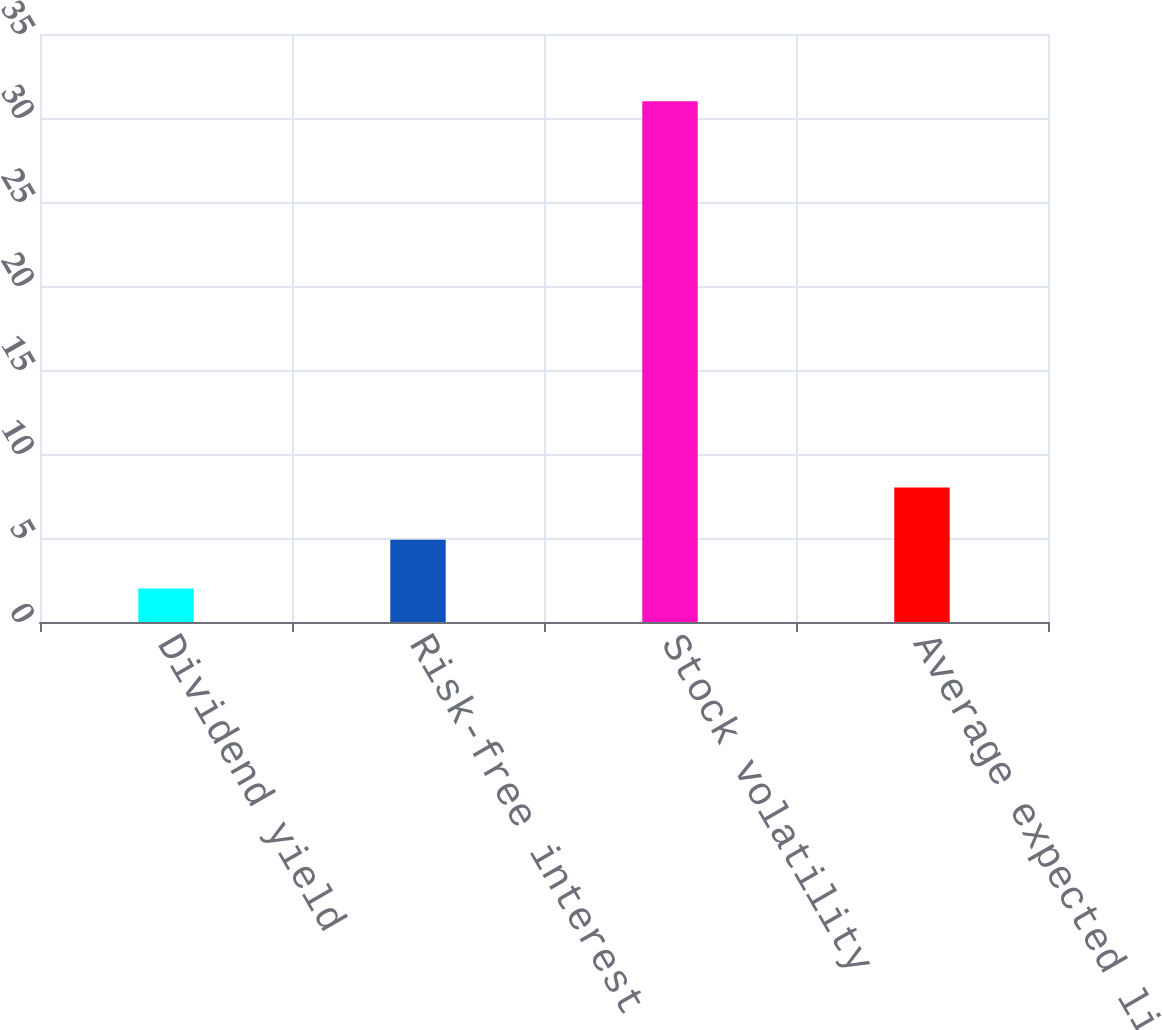<chart> <loc_0><loc_0><loc_500><loc_500><bar_chart><fcel>Dividend yield<fcel>Risk-free interest rate<fcel>Stock volatility<fcel>Average expected life (years)<nl><fcel>2<fcel>4.9<fcel>31<fcel>8<nl></chart> 